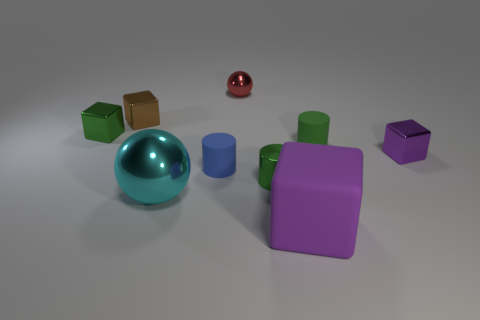Subtract 1 cubes. How many cubes are left? 3 Add 1 tiny shiny cylinders. How many objects exist? 10 Subtract all cylinders. How many objects are left? 6 Subtract 0 gray blocks. How many objects are left? 9 Subtract all blue cylinders. Subtract all green metallic things. How many objects are left? 6 Add 4 small green metallic cylinders. How many small green metallic cylinders are left? 5 Add 9 purple shiny objects. How many purple shiny objects exist? 10 